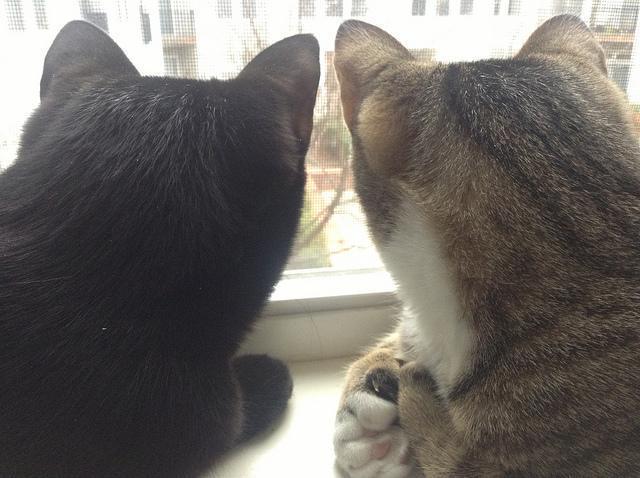How many cats are there?
Give a very brief answer. 2. 